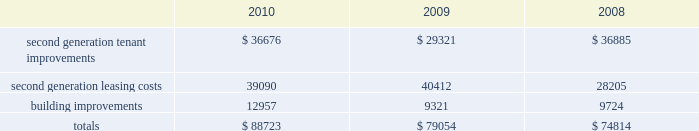34| | duke realty corporation annual report 2010 value of $ 173.9 million for which our 80% ( 80 % ) share of net proceeds totaled $ 138.3 million .
We expect , and are under contract , to sell additional buildings to duke/ princeton , llc by the end of the second quarter 2011 , subject to financing and other customary closing conditions .
The total 2011 sale is expected to consist of 13 office buildings , totaling over 2.0 million square feet , with an agreed upon value of $ 342.8 million , and is expected to generate proceeds of $ 274.2 million for the 80% ( 80 % ) portion that we sell .
Uses of liquidity our principal uses of liquidity include the following : 2022 accretive property investment ; 2022 leasing/capital costs ; 2022 dividends and distributions to shareholders and unitholders ; 2022 long-term debt maturities ; 2022 repurchases of outstanding debt and preferred stock ; and 2022 other contractual obligations .
Property investment we evaluate development and acquisition opportunities based upon market outlook , supply and long-term growth potential .
Our ability to make future property investments is dependent upon our continued access to our longer-term sources of liquidity including the issuances of debt or equity securities as well as generating cash flow by disposing of selected properties .
In light of current economic conditions , management continues to evaluate our investment priorities and is focused on accretive growth .
We have continued to operate at a substantially reduced level of new development activity , as compared to recent years , and are focused on the core operations of our existing base of properties .
Leasing/capital costs tenant improvements and leasing costs to re-let rental space that had been previously under lease to tenants are referred to as second generation expenditures .
Building improvements that are not specific to any tenant but serve to improve integral components of our real estate properties are also second generation expenditures .
One of our principal uses of our liquidity is to fund the second generation leasing/capital expenditures of our real estate investments .
The following is a summary of our second generation capital expenditures for the years ended december 31 , 2010 , 2009 and 2008 , respectively ( in thousands ) : .

In 2009 what was the percent of the total second generation capital expenditures associated with leasing costs? 
Computations: (40412 / 79054)
Answer: 0.51119. 